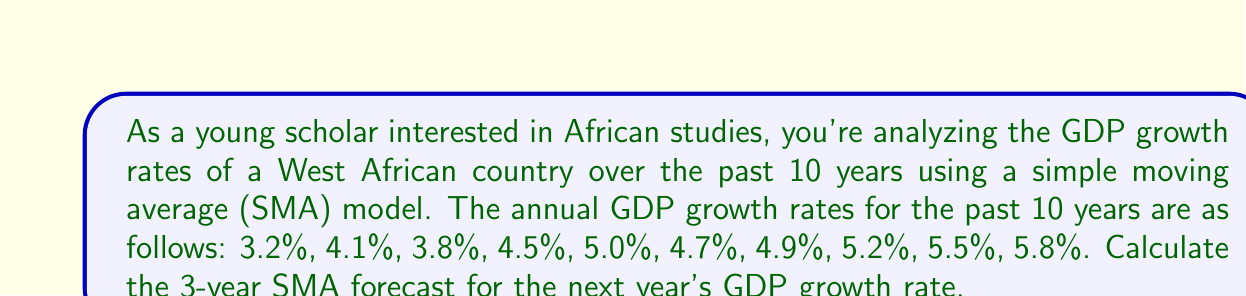Solve this math problem. To solve this problem, we'll follow these steps:

1. Understand the Simple Moving Average (SMA) model:
   The n-year SMA is calculated by taking the average of the most recent n years of data.

2. Identify the most recent 3 years of data:
   The last three years' GDP growth rates are 5.2%, 5.5%, and 5.8%.

3. Calculate the 3-year SMA:
   $$SMA = \frac{5.2\% + 5.5\% + 5.8\%}{3}$$

4. Perform the calculation:
   $$SMA = \frac{5.2 + 5.5 + 5.8}{3} = \frac{16.5}{3} = 5.5\%$$

5. Interpret the result:
   The 3-year SMA forecast for the next year's GDP growth rate is 5.5%.

This simple forecasting method assumes that the trend observed in the most recent three years will continue into the next year. It's important to note that while this method is straightforward, it doesn't account for more complex economic factors or potential disruptions that could affect GDP growth.
Answer: 5.5% 